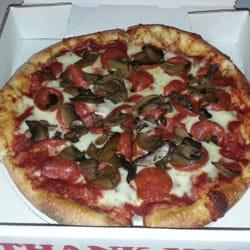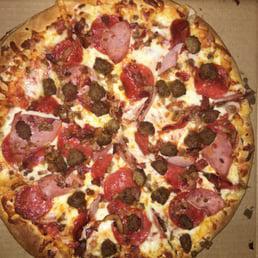The first image is the image on the left, the second image is the image on the right. Examine the images to the left and right. Is the description "All pizzas are round and no individual pizzas have different toppings on different sides." accurate? Answer yes or no. Yes. The first image is the image on the left, the second image is the image on the right. Examine the images to the left and right. Is the description "One of the pizzas has mushrooms on top of the pepperoni toppings." accurate? Answer yes or no. Yes. 